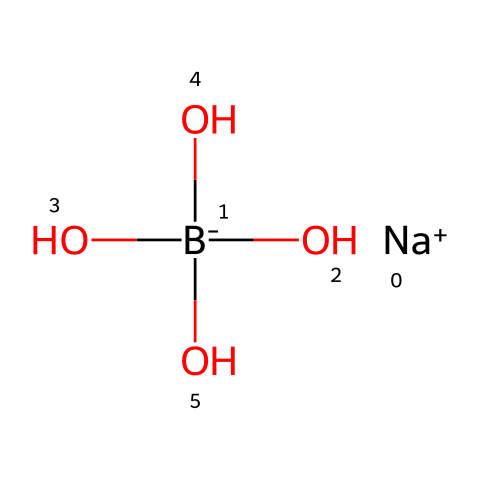What is the total number of oxygen atoms in the chemical structure? The chemical structure given includes three hydroxyl groups (-OH) and one additional hydroxyl group as part of boron, leading to a total of four oxygen atoms.
Answer: four How many boron atoms are present in the structure? The SMILES representation indicates one boron atom, as seen in the presence of the [B-] notation.
Answer: one What type of ion is indicated in the structure? The chemical representation shows [Na+], indicating a sodium ion that carries a positive charge.
Answer: sodium ion What is the overall charge of the boron-containing compound? The structure contains a negative boron ion ([B-]) and a positive sodium ion ([Na+]), resulting in a neutral overall charge when combined.
Answer: neutral What type of cleaning agent does this structure represent? Boron compounds like this can serve as cleaning agents due to their ability to disrupt surface tension and aid in stain removal, thus characterizing it as a boron-based cleaning agent.
Answer: boron-based cleaning agent 